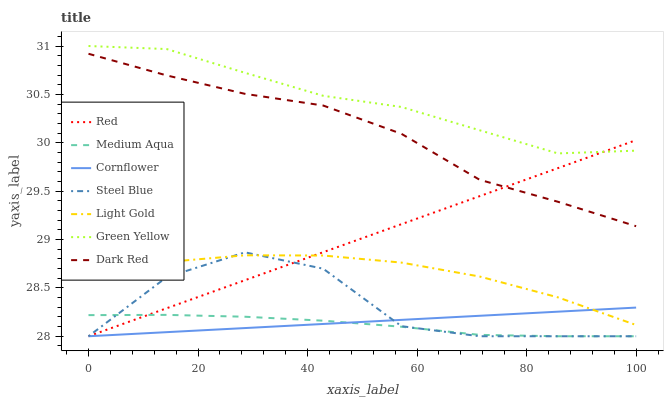Does Medium Aqua have the minimum area under the curve?
Answer yes or no. Yes. Does Green Yellow have the maximum area under the curve?
Answer yes or no. Yes. Does Dark Red have the minimum area under the curve?
Answer yes or no. No. Does Dark Red have the maximum area under the curve?
Answer yes or no. No. Is Cornflower the smoothest?
Answer yes or no. Yes. Is Steel Blue the roughest?
Answer yes or no. Yes. Is Dark Red the smoothest?
Answer yes or no. No. Is Dark Red the roughest?
Answer yes or no. No. Does Cornflower have the lowest value?
Answer yes or no. Yes. Does Dark Red have the lowest value?
Answer yes or no. No. Does Green Yellow have the highest value?
Answer yes or no. Yes. Does Dark Red have the highest value?
Answer yes or no. No. Is Light Gold less than Green Yellow?
Answer yes or no. Yes. Is Green Yellow greater than Light Gold?
Answer yes or no. Yes. Does Cornflower intersect Red?
Answer yes or no. Yes. Is Cornflower less than Red?
Answer yes or no. No. Is Cornflower greater than Red?
Answer yes or no. No. Does Light Gold intersect Green Yellow?
Answer yes or no. No. 